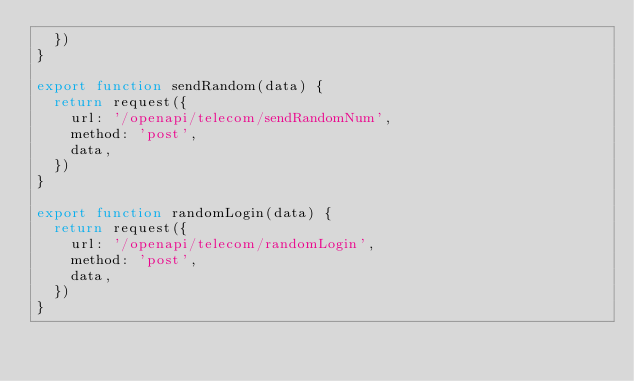<code> <loc_0><loc_0><loc_500><loc_500><_JavaScript_>  })
}

export function sendRandom(data) {
  return request({
    url: '/openapi/telecom/sendRandomNum',
    method: 'post',
    data,
  })
}

export function randomLogin(data) {
  return request({
    url: '/openapi/telecom/randomLogin',
    method: 'post',
    data,
  })
}
</code> 